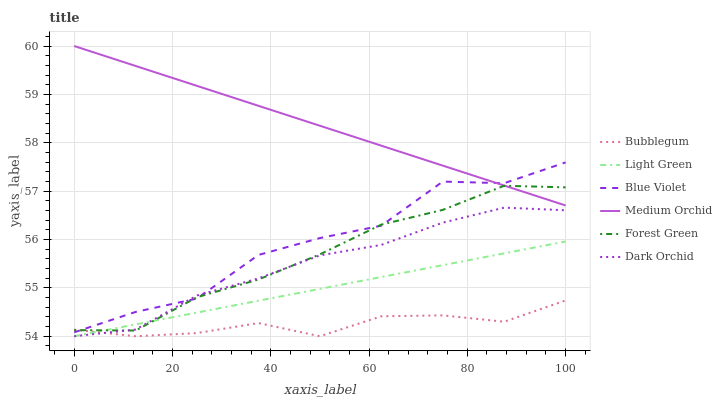Does Bubblegum have the minimum area under the curve?
Answer yes or no. Yes. Does Medium Orchid have the maximum area under the curve?
Answer yes or no. Yes. Does Dark Orchid have the minimum area under the curve?
Answer yes or no. No. Does Dark Orchid have the maximum area under the curve?
Answer yes or no. No. Is Light Green the smoothest?
Answer yes or no. Yes. Is Blue Violet the roughest?
Answer yes or no. Yes. Is Dark Orchid the smoothest?
Answer yes or no. No. Is Dark Orchid the roughest?
Answer yes or no. No. Does Dark Orchid have the lowest value?
Answer yes or no. Yes. Does Forest Green have the lowest value?
Answer yes or no. No. Does Medium Orchid have the highest value?
Answer yes or no. Yes. Does Dark Orchid have the highest value?
Answer yes or no. No. Is Light Green less than Medium Orchid?
Answer yes or no. Yes. Is Medium Orchid greater than Bubblegum?
Answer yes or no. Yes. Does Dark Orchid intersect Bubblegum?
Answer yes or no. Yes. Is Dark Orchid less than Bubblegum?
Answer yes or no. No. Is Dark Orchid greater than Bubblegum?
Answer yes or no. No. Does Light Green intersect Medium Orchid?
Answer yes or no. No. 